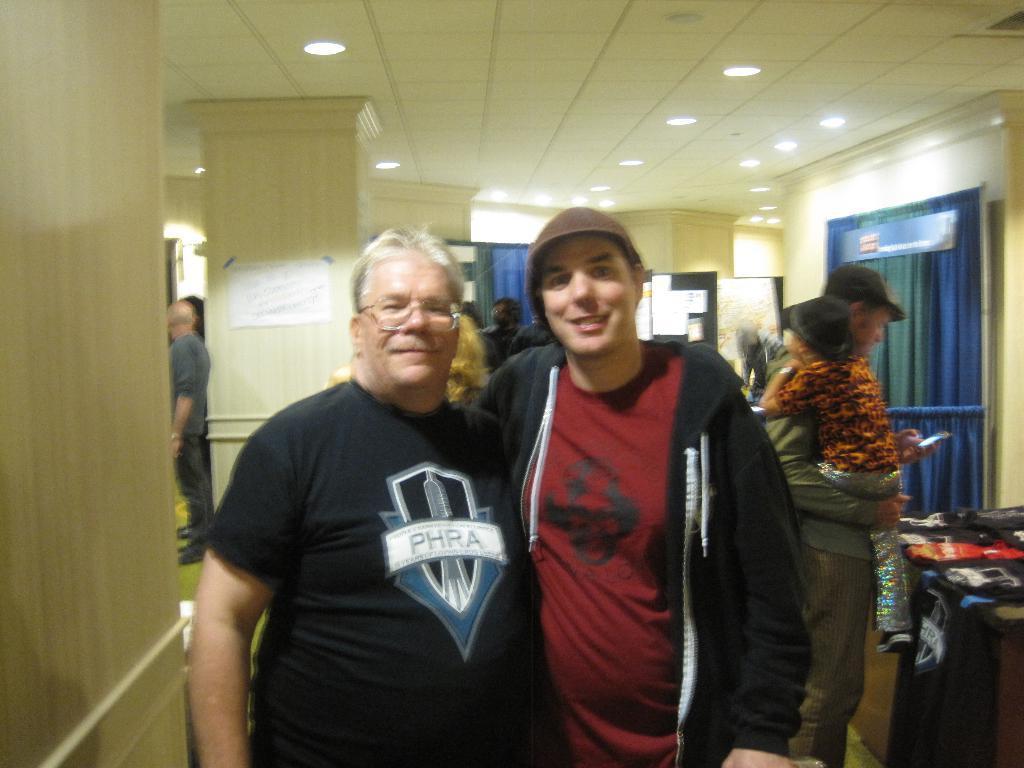How would you summarize this image in a sentence or two? This picture is clicked inside the hall. In the foreground we can see the two persons wearing t-shirts and standing. On the right there is a person holding a kid and a mobile phone and standing on the floor and we can see there are some objects placed on the top of the table. At the top there is a roof and we can see the ceiling lights. In the background we can see the pillars, group of persons, curtains and many other objects. 